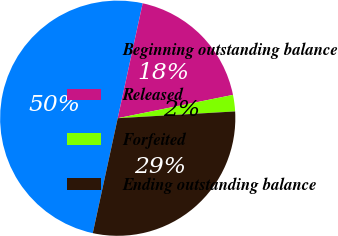Convert chart to OTSL. <chart><loc_0><loc_0><loc_500><loc_500><pie_chart><fcel>Beginning outstanding balance<fcel>Released<fcel>Forfeited<fcel>Ending outstanding balance<nl><fcel>50.0%<fcel>18.42%<fcel>2.26%<fcel>29.32%<nl></chart> 